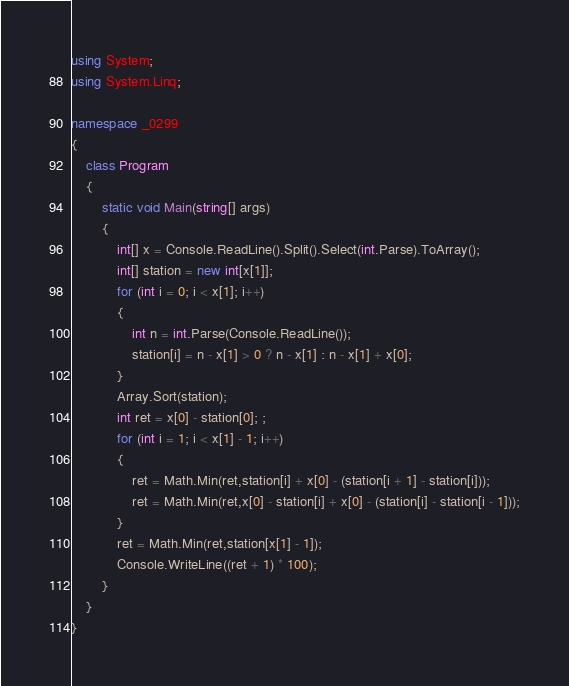Convert code to text. <code><loc_0><loc_0><loc_500><loc_500><_C#_>using System;
using System.Linq;

namespace _0299
{
    class Program
    {
        static void Main(string[] args)
        {
            int[] x = Console.ReadLine().Split().Select(int.Parse).ToArray();
            int[] station = new int[x[1]];
            for (int i = 0; i < x[1]; i++)
            {
                int n = int.Parse(Console.ReadLine());
                station[i] = n - x[1] > 0 ? n - x[1] : n - x[1] + x[0];
            }
            Array.Sort(station);
            int ret = x[0] - station[0]; ;
            for (int i = 1; i < x[1] - 1; i++)
            {
                ret = Math.Min(ret,station[i] + x[0] - (station[i + 1] - station[i]));
                ret = Math.Min(ret,x[0] - station[i] + x[0] - (station[i] - station[i - 1]));
            }
            ret = Math.Min(ret,station[x[1] - 1]);
            Console.WriteLine((ret + 1) * 100);
        }
    }
}</code> 